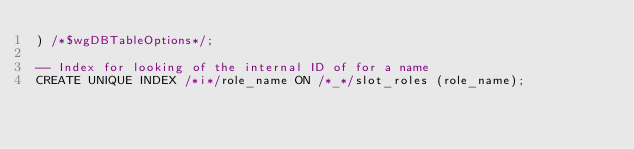<code> <loc_0><loc_0><loc_500><loc_500><_SQL_>) /*$wgDBTableOptions*/;

-- Index for looking of the internal ID of for a name
CREATE UNIQUE INDEX /*i*/role_name ON /*_*/slot_roles (role_name);</code> 